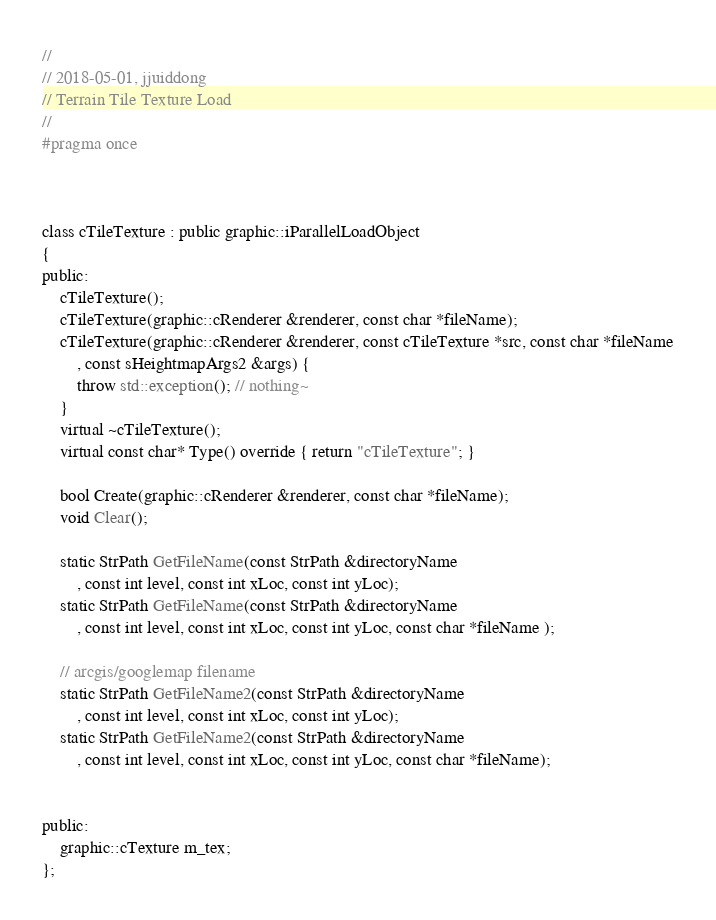Convert code to text. <code><loc_0><loc_0><loc_500><loc_500><_C_>//
// 2018-05-01, jjuiddong
// Terrain Tile Texture Load
//
#pragma once



class cTileTexture : public graphic::iParallelLoadObject
{
public:
	cTileTexture();
	cTileTexture(graphic::cRenderer &renderer, const char *fileName);
	cTileTexture(graphic::cRenderer &renderer, const cTileTexture *src, const char *fileName
		, const sHeightmapArgs2 &args) {
		throw std::exception(); // nothing~
	}
	virtual ~cTileTexture();
	virtual const char* Type() override { return "cTileTexture"; }
	
	bool Create(graphic::cRenderer &renderer, const char *fileName);
	void Clear();

	static StrPath GetFileName(const StrPath &directoryName
		, const int level, const int xLoc, const int yLoc);
	static StrPath GetFileName(const StrPath &directoryName
		, const int level, const int xLoc, const int yLoc, const char *fileName );

	// arcgis/googlemap filename
	static StrPath GetFileName2(const StrPath &directoryName
		, const int level, const int xLoc, const int yLoc);
	static StrPath GetFileName2(const StrPath &directoryName
		, const int level, const int xLoc, const int yLoc, const char *fileName);


public:
	graphic::cTexture m_tex;
};
</code> 